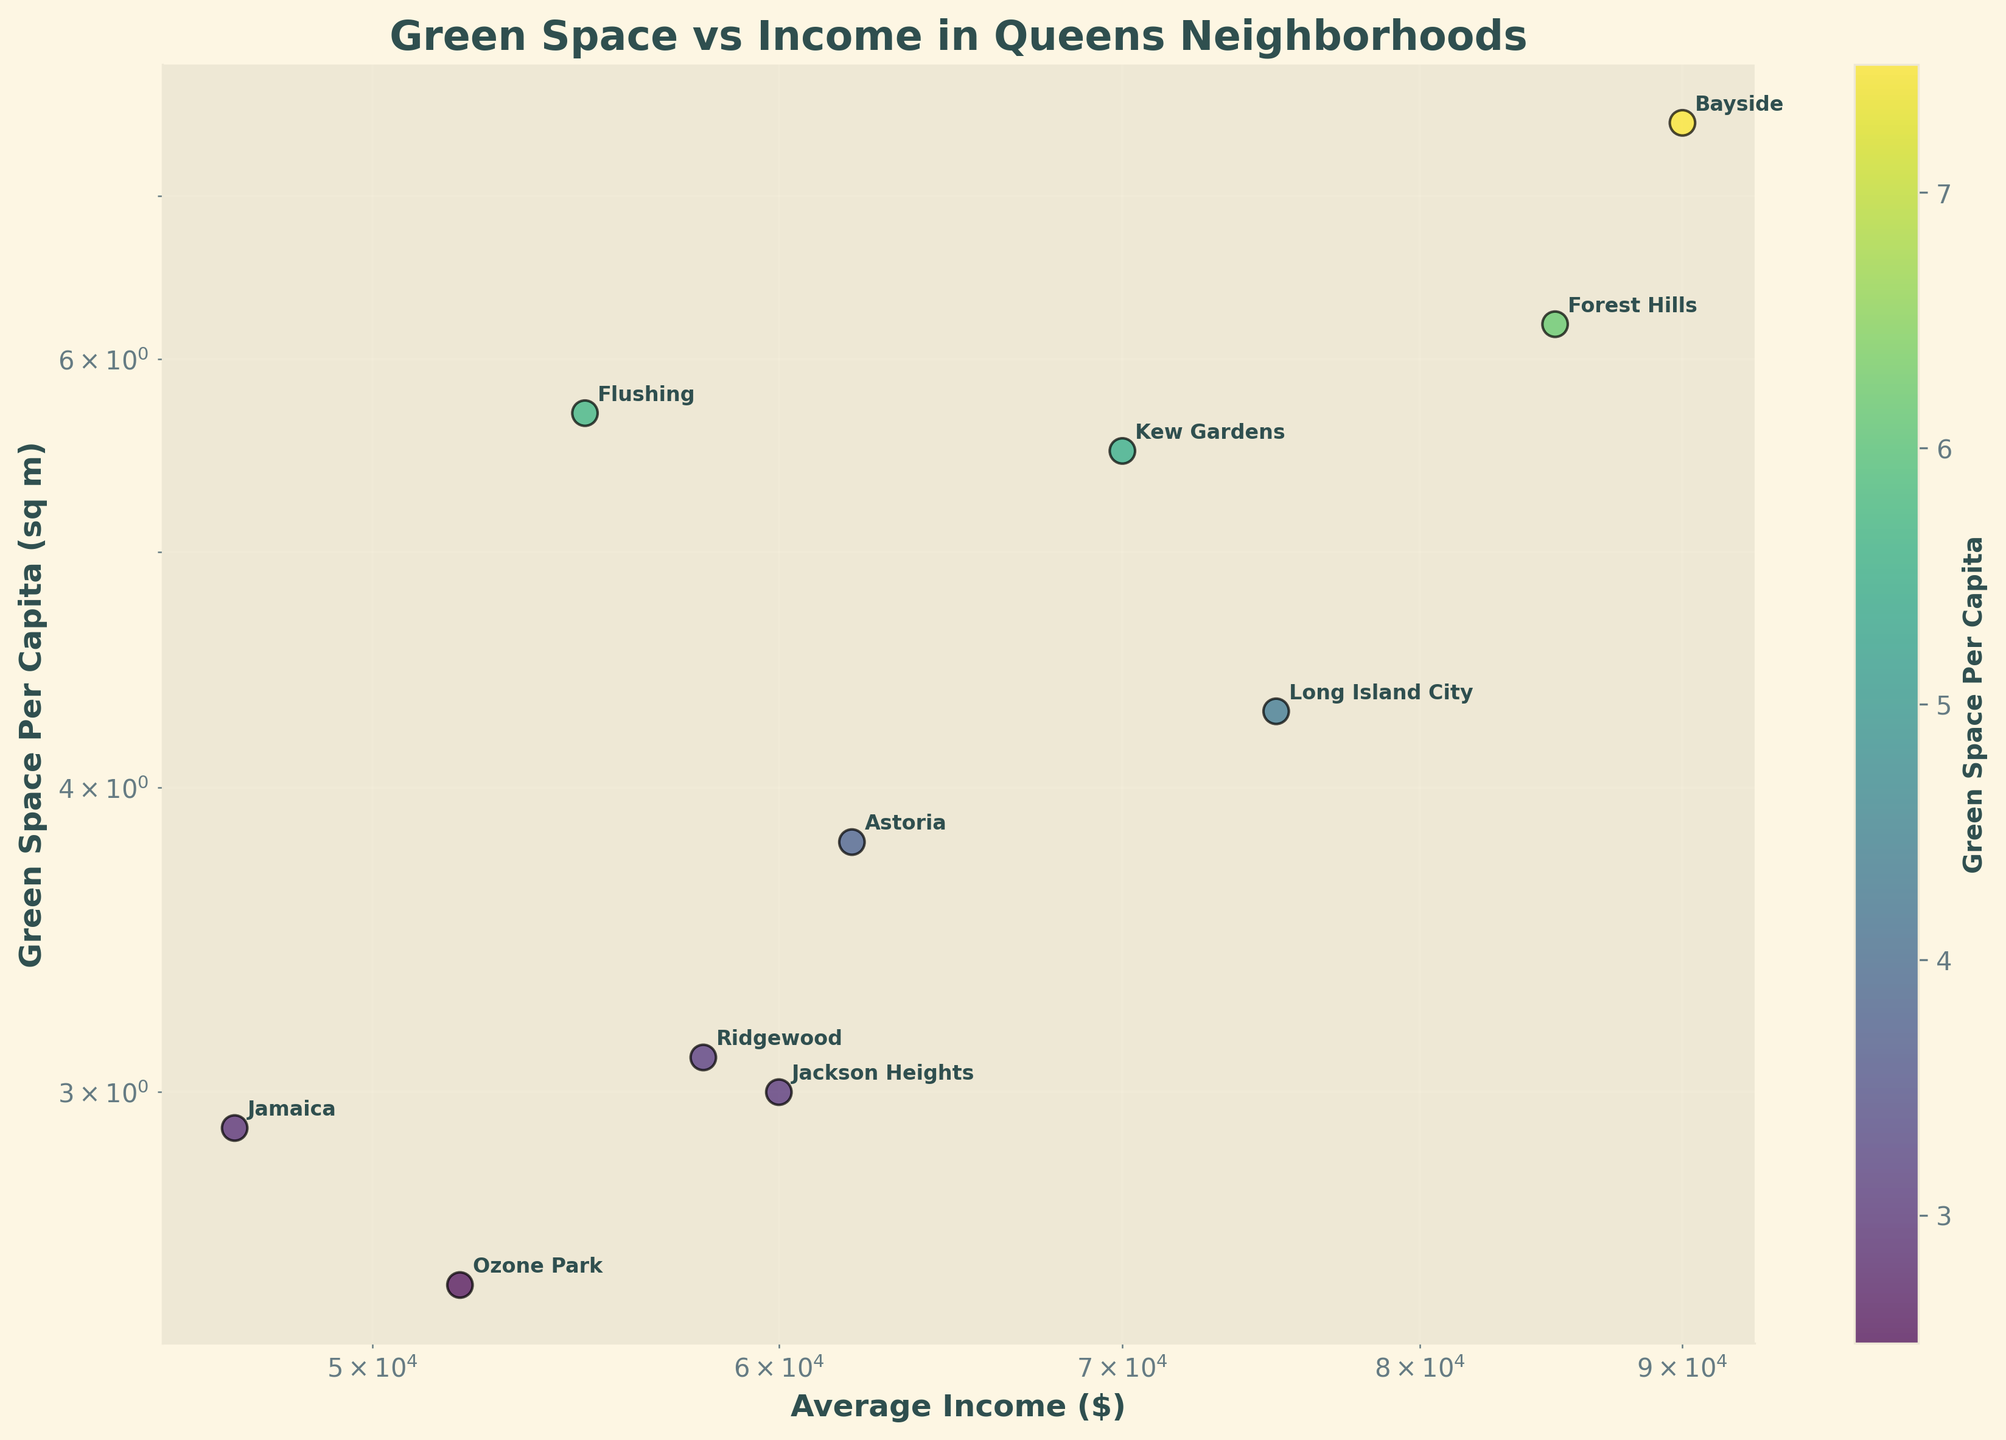What is the title of the plot? The title is displayed prominently at the top of the plot and describes the content of the plot, which is "Green Space vs Income in Queens Neighborhoods".
Answer: Green Space vs Income in Queens Neighborhoods What color scheme is used for the scatter plot data points? The scatter plot uses a color scheme provided by the 'viridis' colormap, which changes from yellow to green to purple based on the value of green space per capita.
Answer: viridis Which neighborhood has the highest green space per capita? Examine the y-axis, which represents green space per capita. The neighborhood associated with the highest point on this axis is Bayside.
Answer: Bayside How is the relationship between average income and green space per capita depicted? Both axes are on a log scale, making the relationship appear compressed but more comparable over wide ranges of values.
Answer: Log-log scale Is there a neighborhood with both low average income and low green space per capita? Look for a neighborhood on the lower left quadrant of the plot. Jamaica falls into this category with low values on both axes.
Answer: Jamaica What is the lowest green space per capita shown, and which neighborhood does it correspond to? The lowest point on the y-axis corresponds to Ozone Park, with a value of 2.5 sq m per capita.
Answer: Ozone Park, 2.5 sq m per capita Is there a correlation between higher average income and higher green space per capita? Look at the overall trend of the data points on the plot. Higher incomes generally correlate with more green space, noticeable through the upward trend.
Answer: Yes Which neighborhood has a higher average income but lower green space per capita when compared to Flushing? From the data points, Long Island City has a higher average income than Flushing ($75,000 vs $55,000) but less green space per capita (4.3 vs 5.7 sq m).
Answer: Long Island City How many neighborhoods are plotted in the figure? Count the number of different annotated points on the scatter plot, which corresponds to the different neighborhoods. There are a total of 10 points.
Answer: 10 Which two neighborhoods are closest in values on the plot, indicating similar income and green space per capita? By visually inspecting the plot for proximity, Ridgewood and Jackson Heights have similar positions, with Ridgewood having slightly higher income and both having similar green space values.
Answer: Ridgewood and Jackson Heights 